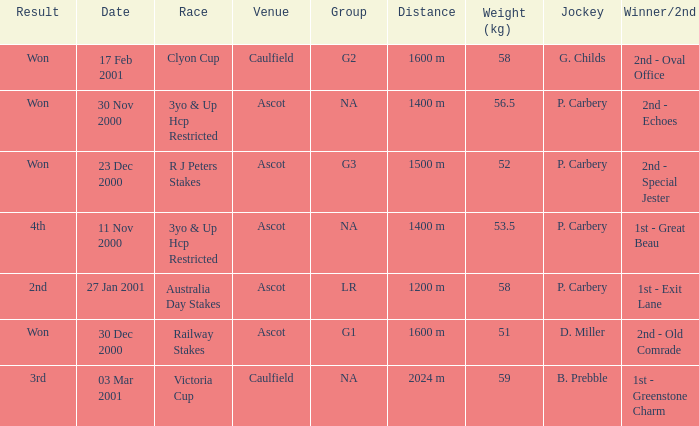What group info is available for the 56.5 kg weight? NA. 